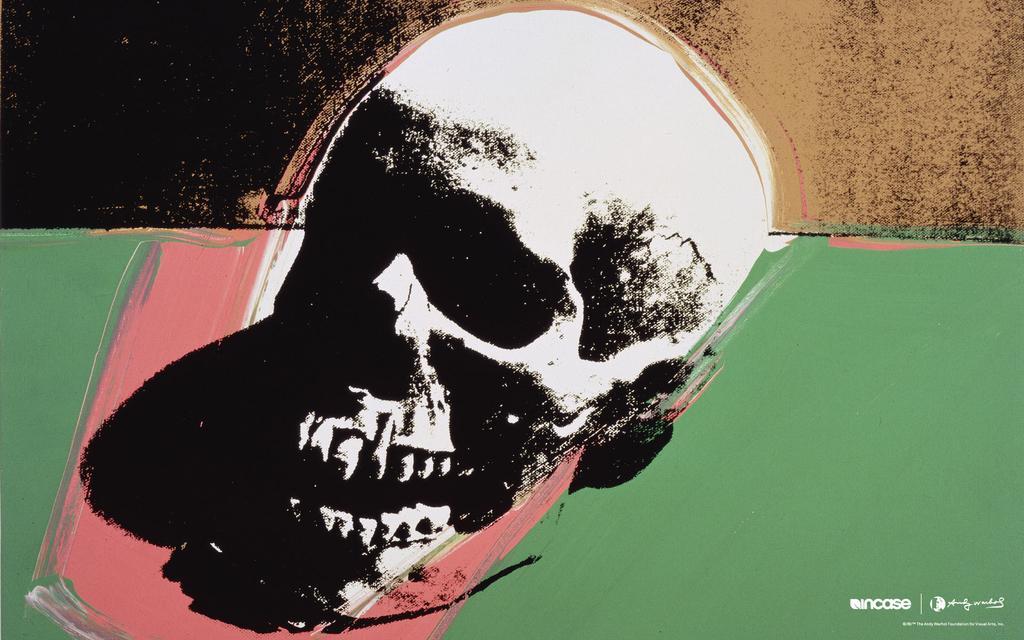Could you give a brief overview of what you see in this image? In the center of the image there is a wall. On the wall, we can see some painting, in which we can see one skill, which is in black and white color. At the bottom right side of the image, we can see some text. 